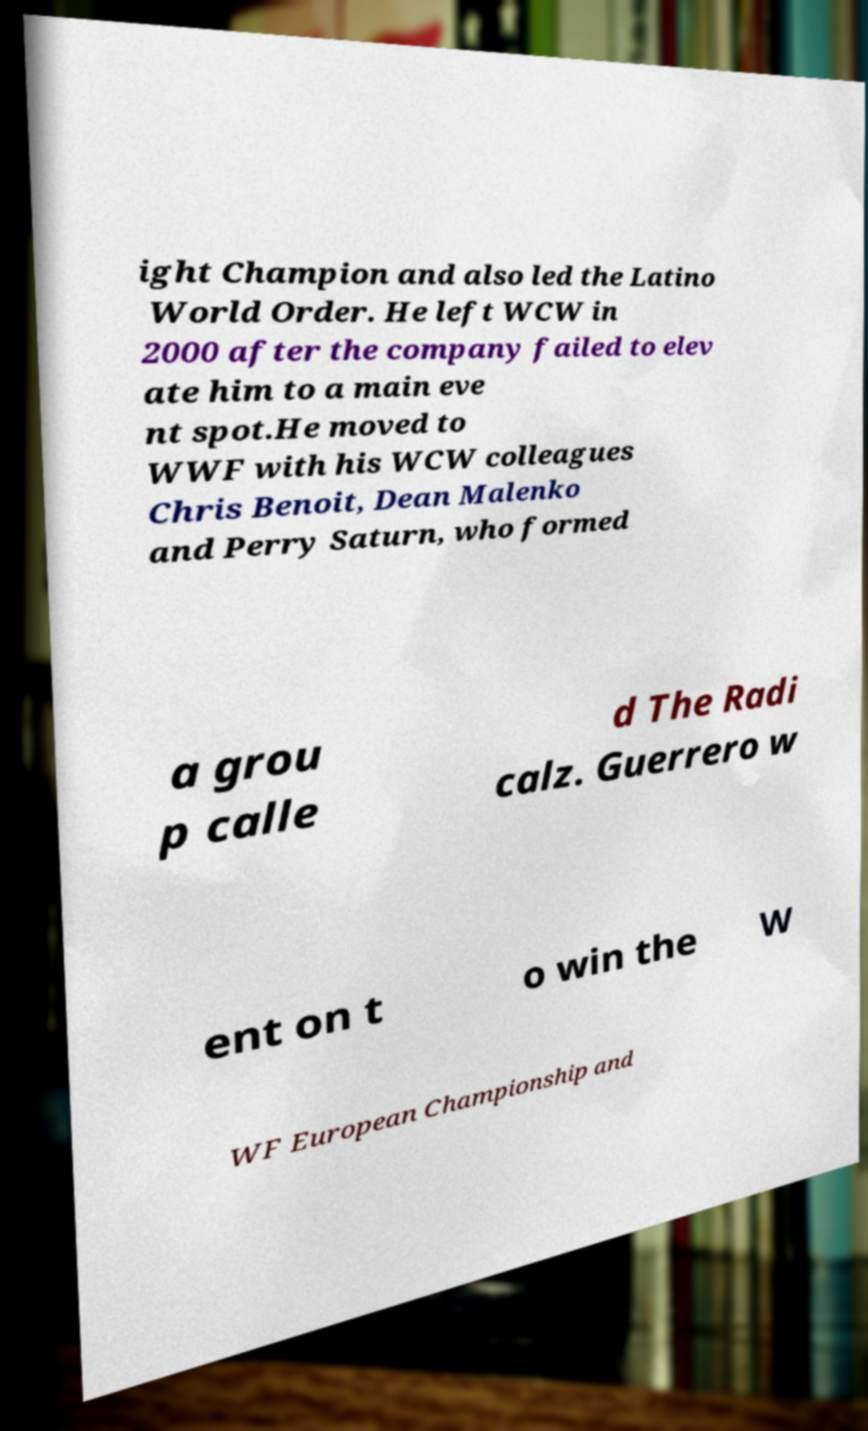Could you assist in decoding the text presented in this image and type it out clearly? ight Champion and also led the Latino World Order. He left WCW in 2000 after the company failed to elev ate him to a main eve nt spot.He moved to WWF with his WCW colleagues Chris Benoit, Dean Malenko and Perry Saturn, who formed a grou p calle d The Radi calz. Guerrero w ent on t o win the W WF European Championship and 